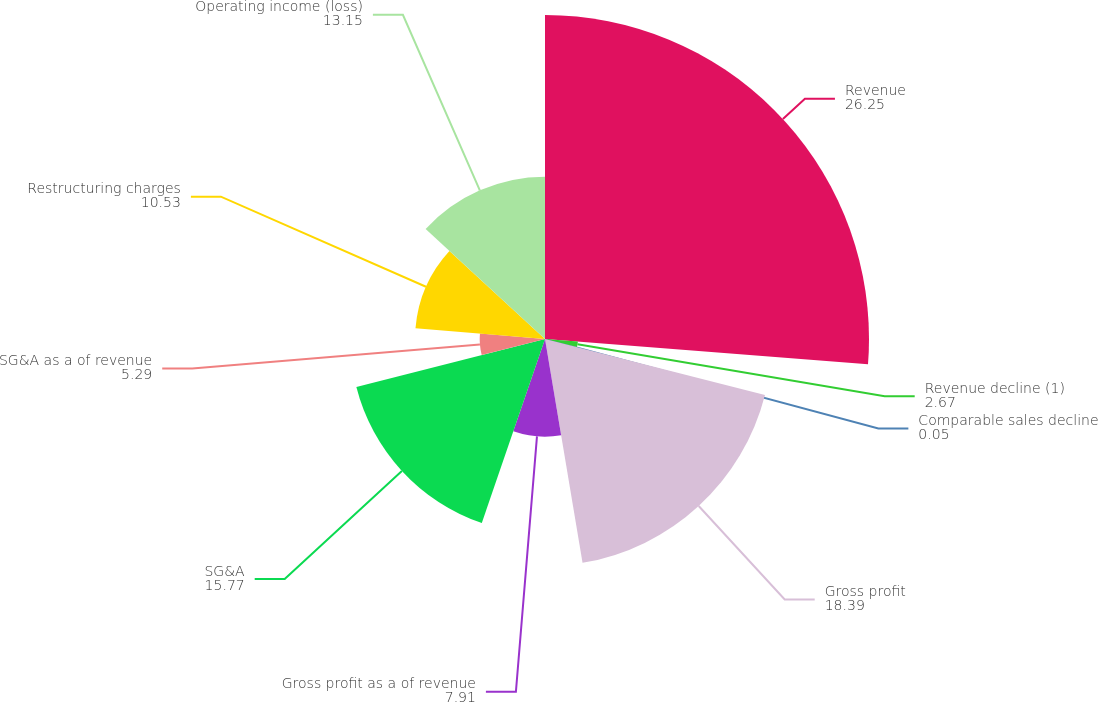Convert chart. <chart><loc_0><loc_0><loc_500><loc_500><pie_chart><fcel>Revenue<fcel>Revenue decline (1)<fcel>Comparable sales decline<fcel>Gross profit<fcel>Gross profit as a of revenue<fcel>SG&A<fcel>SG&A as a of revenue<fcel>Restructuring charges<fcel>Operating income (loss)<nl><fcel>26.25%<fcel>2.67%<fcel>0.05%<fcel>18.39%<fcel>7.91%<fcel>15.77%<fcel>5.29%<fcel>10.53%<fcel>13.15%<nl></chart> 